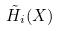Convert formula to latex. <formula><loc_0><loc_0><loc_500><loc_500>\tilde { H } _ { i } ( X )</formula> 